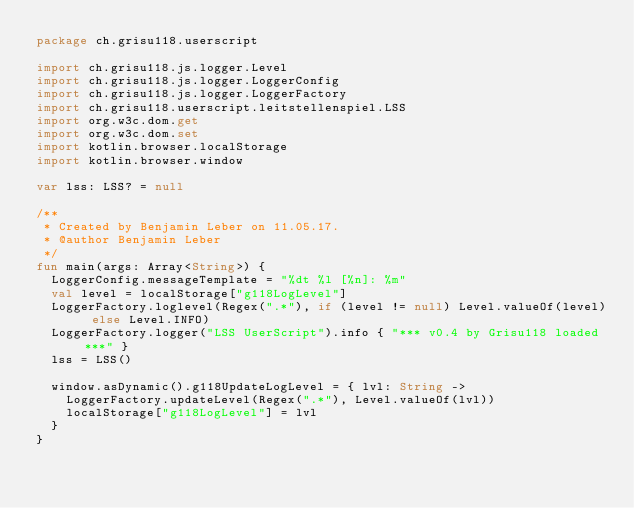Convert code to text. <code><loc_0><loc_0><loc_500><loc_500><_Kotlin_>package ch.grisu118.userscript

import ch.grisu118.js.logger.Level
import ch.grisu118.js.logger.LoggerConfig
import ch.grisu118.js.logger.LoggerFactory
import ch.grisu118.userscript.leitstellenspiel.LSS
import org.w3c.dom.get
import org.w3c.dom.set
import kotlin.browser.localStorage
import kotlin.browser.window

var lss: LSS? = null

/**
 * Created by Benjamin Leber on 11.05.17.
 * @author Benjamin Leber
 */
fun main(args: Array<String>) {
  LoggerConfig.messageTemplate = "%dt %l [%n]: %m"
  val level = localStorage["g118LogLevel"]
  LoggerFactory.loglevel(Regex(".*"), if (level != null) Level.valueOf(level) else Level.INFO)
  LoggerFactory.logger("LSS UserScript").info { "*** v0.4 by Grisu118 loaded ***" }
  lss = LSS()

  window.asDynamic().g118UpdateLogLevel = { lvl: String ->
    LoggerFactory.updateLevel(Regex(".*"), Level.valueOf(lvl))
    localStorage["g118LogLevel"] = lvl
  }
}

</code> 